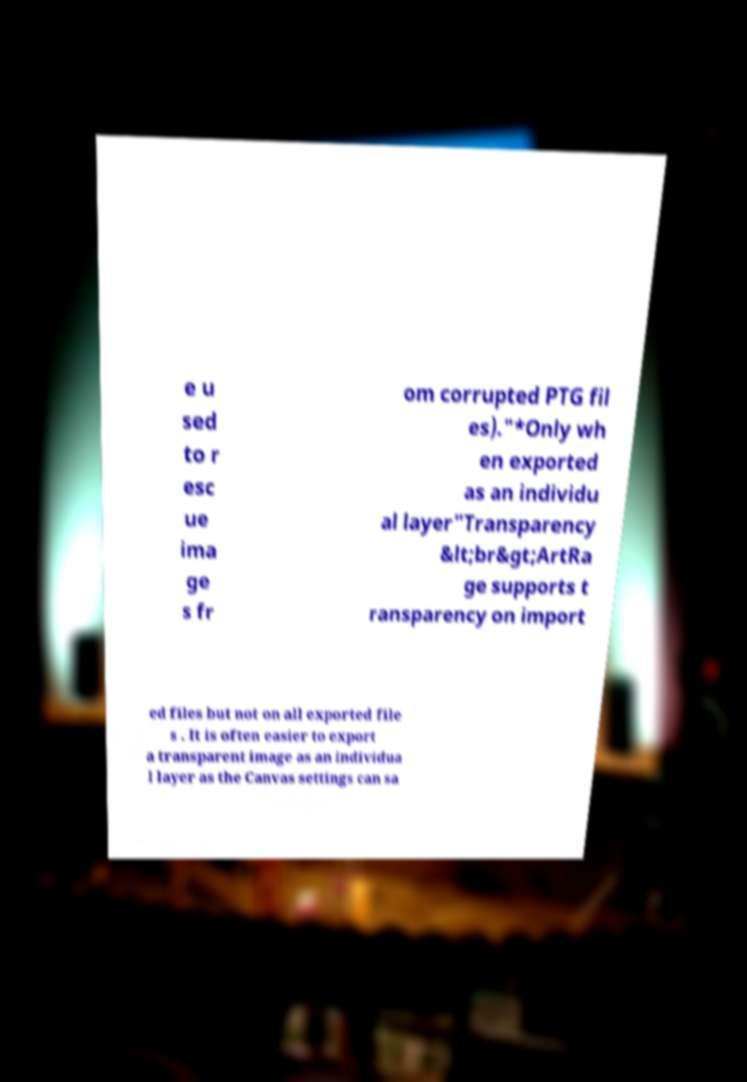Please read and relay the text visible in this image. What does it say? e u sed to r esc ue ima ge s fr om corrupted PTG fil es)."*Only wh en exported as an individu al layer"Transparency &lt;br&gt;ArtRa ge supports t ransparency on import ed files but not on all exported file s . It is often easier to export a transparent image as an individua l layer as the Canvas settings can sa 